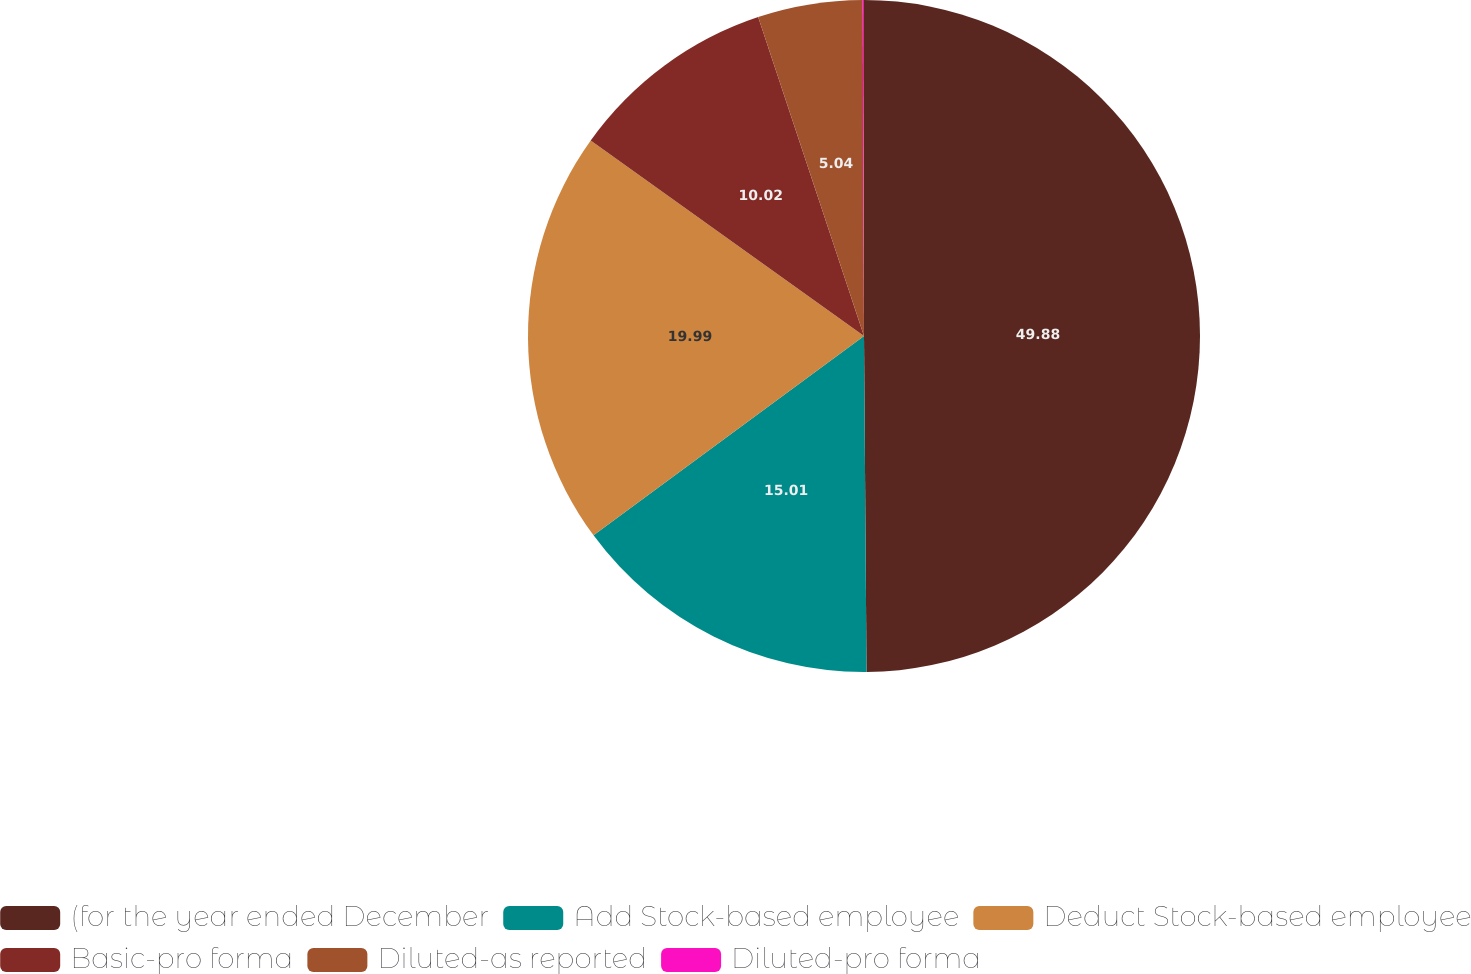Convert chart. <chart><loc_0><loc_0><loc_500><loc_500><pie_chart><fcel>(for the year ended December<fcel>Add Stock-based employee<fcel>Deduct Stock-based employee<fcel>Basic-pro forma<fcel>Diluted-as reported<fcel>Diluted-pro forma<nl><fcel>49.88%<fcel>15.01%<fcel>19.99%<fcel>10.02%<fcel>5.04%<fcel>0.06%<nl></chart> 